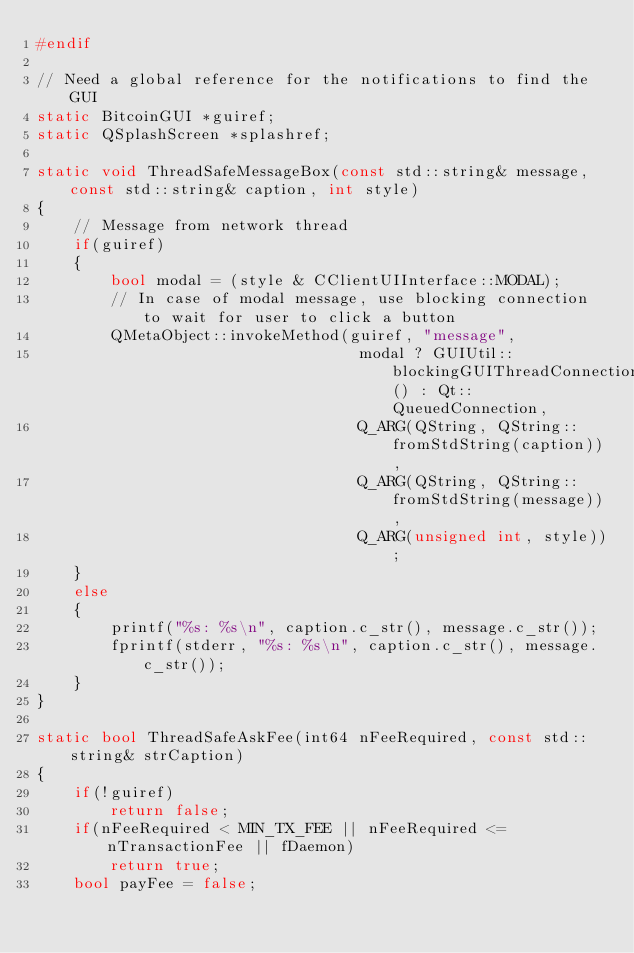<code> <loc_0><loc_0><loc_500><loc_500><_C++_>#endif

// Need a global reference for the notifications to find the GUI
static BitcoinGUI *guiref;
static QSplashScreen *splashref;

static void ThreadSafeMessageBox(const std::string& message, const std::string& caption, int style)
{
    // Message from network thread
    if(guiref)
    {
        bool modal = (style & CClientUIInterface::MODAL);
        // In case of modal message, use blocking connection to wait for user to click a button
        QMetaObject::invokeMethod(guiref, "message",
                                   modal ? GUIUtil::blockingGUIThreadConnection() : Qt::QueuedConnection,
                                   Q_ARG(QString, QString::fromStdString(caption)),
                                   Q_ARG(QString, QString::fromStdString(message)),
                                   Q_ARG(unsigned int, style));
    }
    else
    {
        printf("%s: %s\n", caption.c_str(), message.c_str());
        fprintf(stderr, "%s: %s\n", caption.c_str(), message.c_str());
    }
}

static bool ThreadSafeAskFee(int64 nFeeRequired, const std::string& strCaption)
{
    if(!guiref)
        return false;
    if(nFeeRequired < MIN_TX_FEE || nFeeRequired <= nTransactionFee || fDaemon)
        return true;
    bool payFee = false;
</code> 